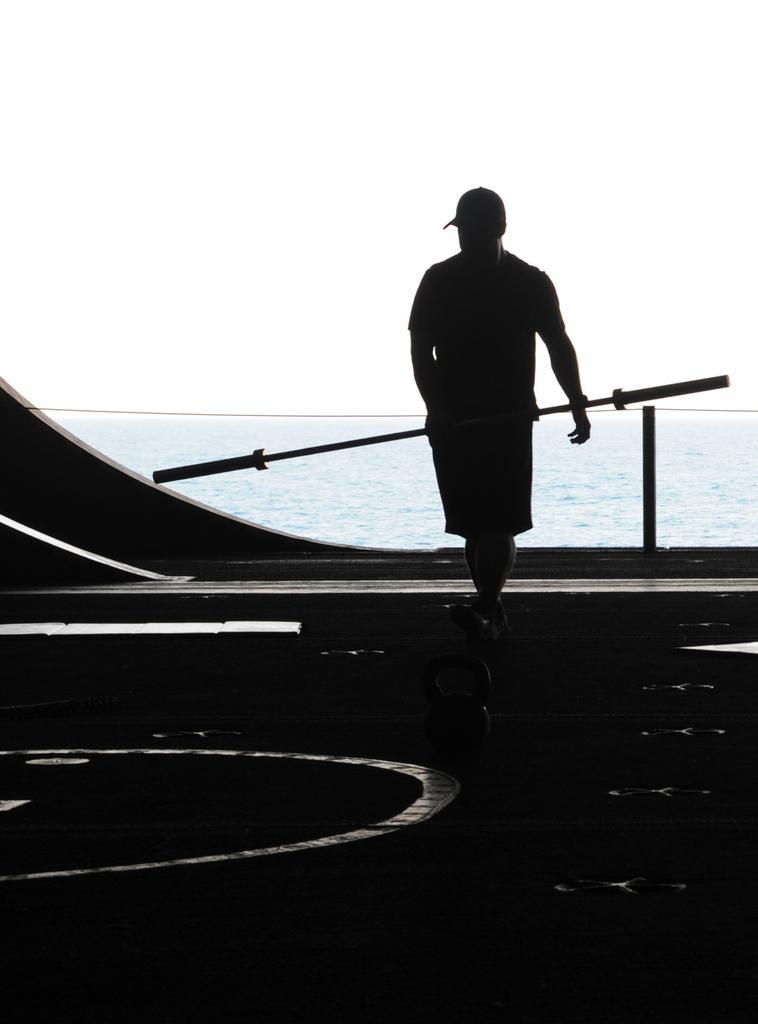In one or two sentences, can you explain what this image depicts? In this picture there is a man who is holding a rad. In the background we can see the ocean. At the top there is a sky. 